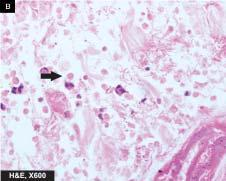what are seen at the margin of ulcer?
Answer the question using a single word or phrase. Trophozoites of entamoeba histolytica 